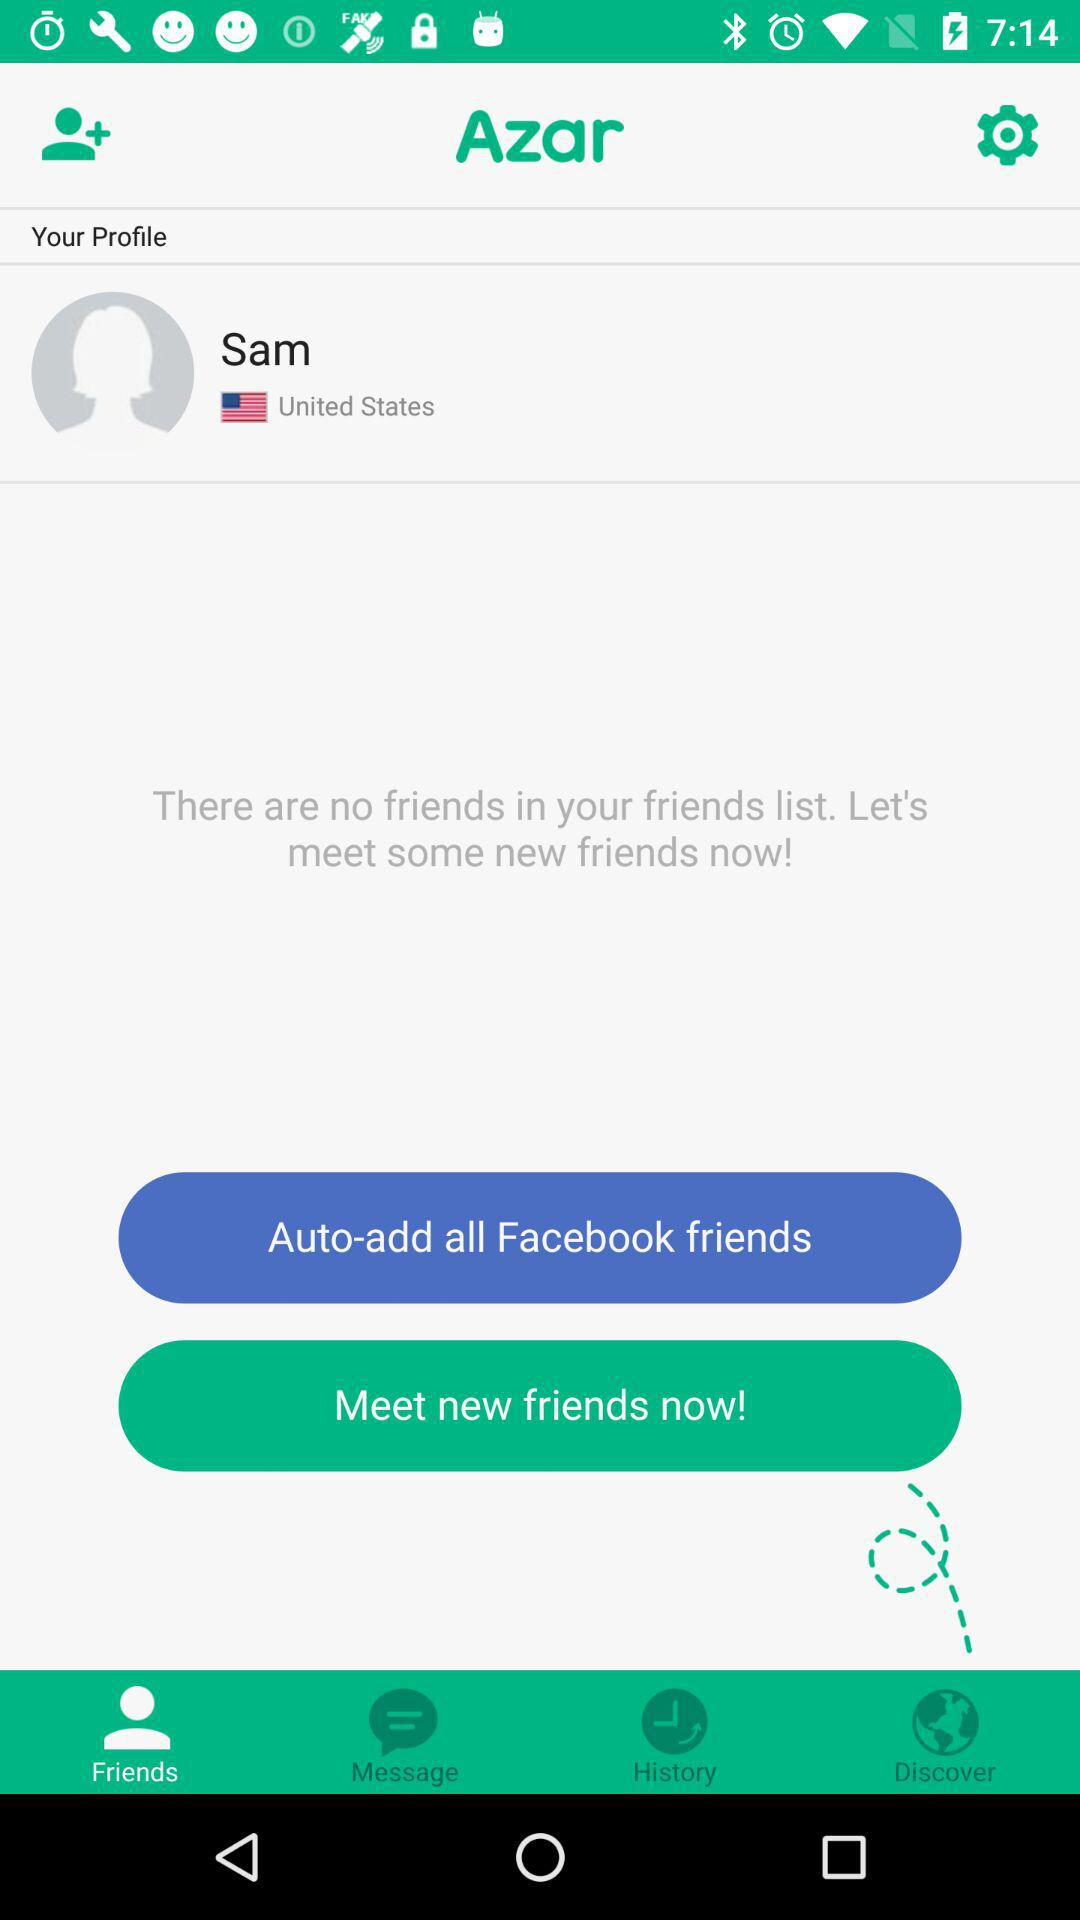What is the application name? The application name is "Azar". 